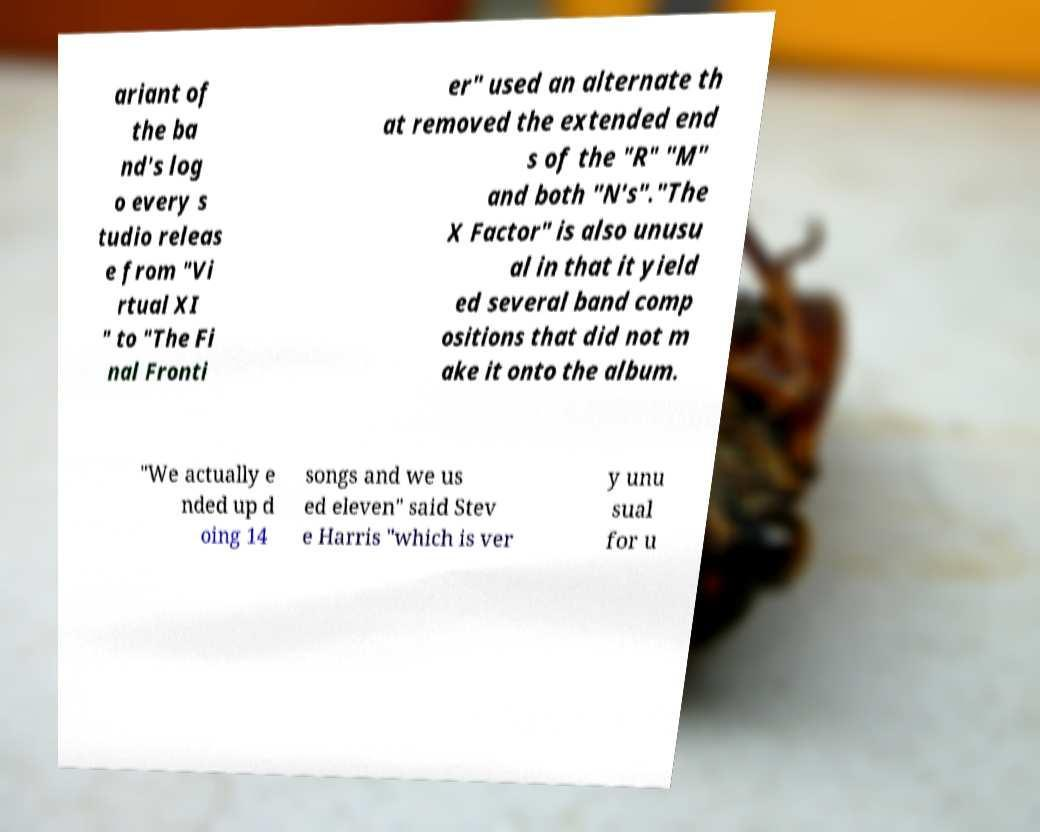There's text embedded in this image that I need extracted. Can you transcribe it verbatim? ariant of the ba nd's log o every s tudio releas e from "Vi rtual XI " to "The Fi nal Fronti er" used an alternate th at removed the extended end s of the "R" "M" and both "N's"."The X Factor" is also unusu al in that it yield ed several band comp ositions that did not m ake it onto the album. "We actually e nded up d oing 14 songs and we us ed eleven" said Stev e Harris "which is ver y unu sual for u 